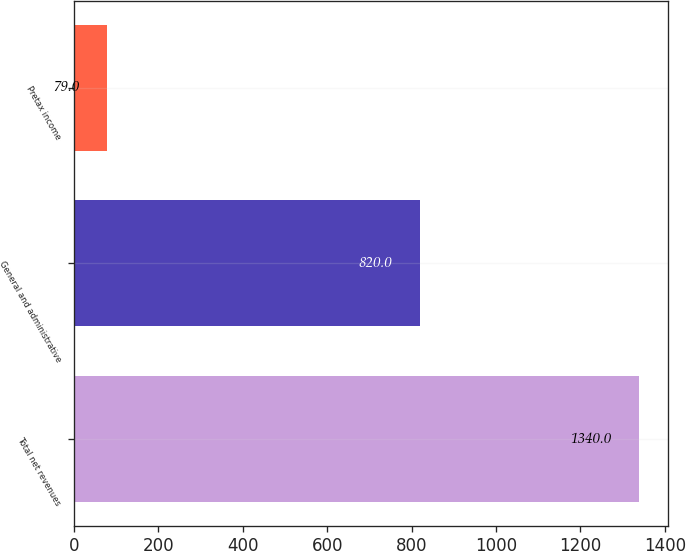Convert chart. <chart><loc_0><loc_0><loc_500><loc_500><bar_chart><fcel>Total net revenues<fcel>General and administrative<fcel>Pretax income<nl><fcel>1340<fcel>820<fcel>79<nl></chart> 